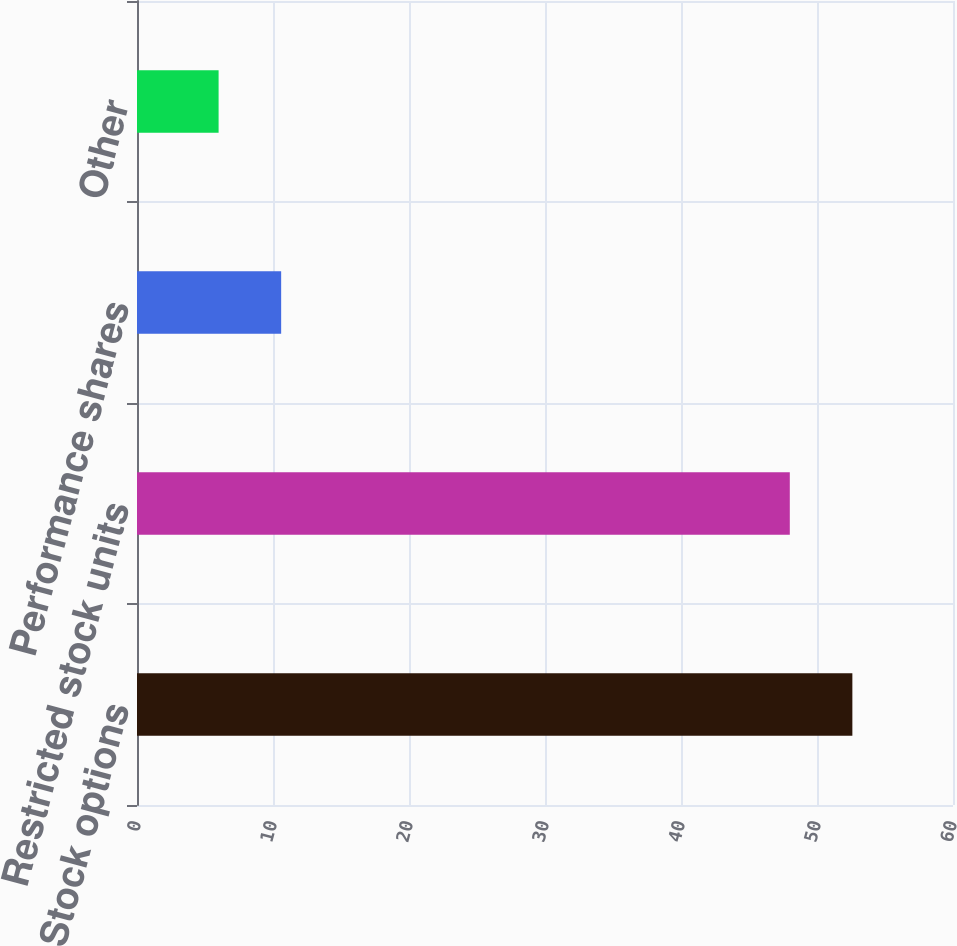Convert chart to OTSL. <chart><loc_0><loc_0><loc_500><loc_500><bar_chart><fcel>Stock options<fcel>Restricted stock units<fcel>Performance shares<fcel>Other<nl><fcel>52.6<fcel>48<fcel>10.6<fcel>6<nl></chart> 